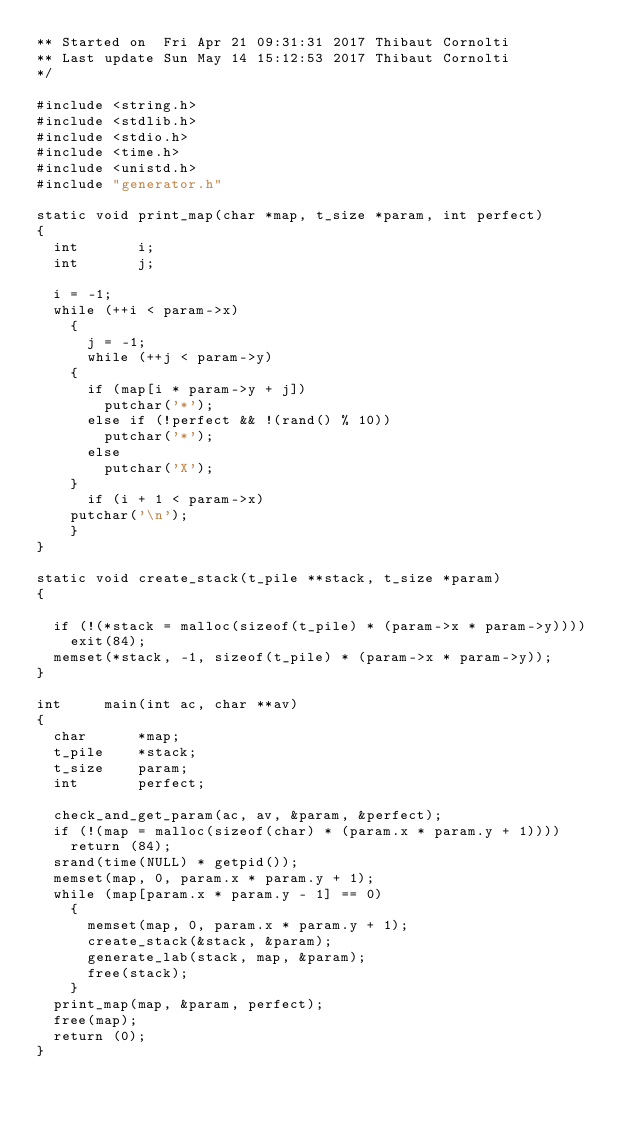Convert code to text. <code><loc_0><loc_0><loc_500><loc_500><_C_>** Started on  Fri Apr 21 09:31:31 2017 Thibaut Cornolti
** Last update Sun May 14 15:12:53 2017 Thibaut Cornolti
*/

#include <string.h>
#include <stdlib.h>
#include <stdio.h>
#include <time.h>
#include <unistd.h>
#include "generator.h"

static void	print_map(char *map, t_size *param, int perfect)
{
  int		i;
  int		j;

  i = -1;
  while (++i < param->x)
    {
      j = -1;
      while (++j < param->y)
	{
	  if (map[i * param->y + j])
	    putchar('*');
	  else if (!perfect && !(rand() % 10))
	    putchar('*');
	  else
	    putchar('X');
	}
      if (i + 1 < param->x)
	putchar('\n');
    }
}

static void	create_stack(t_pile **stack, t_size *param)
{

  if (!(*stack = malloc(sizeof(t_pile) * (param->x * param->y))))
    exit(84);
  memset(*stack, -1, sizeof(t_pile) * (param->x * param->y));
}

int		main(int ac, char **av)
{
  char		*map;
  t_pile	*stack;
  t_size	param;
  int		perfect;

  check_and_get_param(ac, av, &param, &perfect);
  if (!(map = malloc(sizeof(char) * (param.x * param.y + 1))))
    return (84);
  srand(time(NULL) * getpid());
  memset(map, 0, param.x * param.y + 1);
  while (map[param.x * param.y - 1] == 0)
    {
      memset(map, 0, param.x * param.y + 1);
      create_stack(&stack, &param);
      generate_lab(stack, map, &param);
      free(stack);
    }
  print_map(map, &param, perfect);
  free(map);
  return (0);
}
</code> 